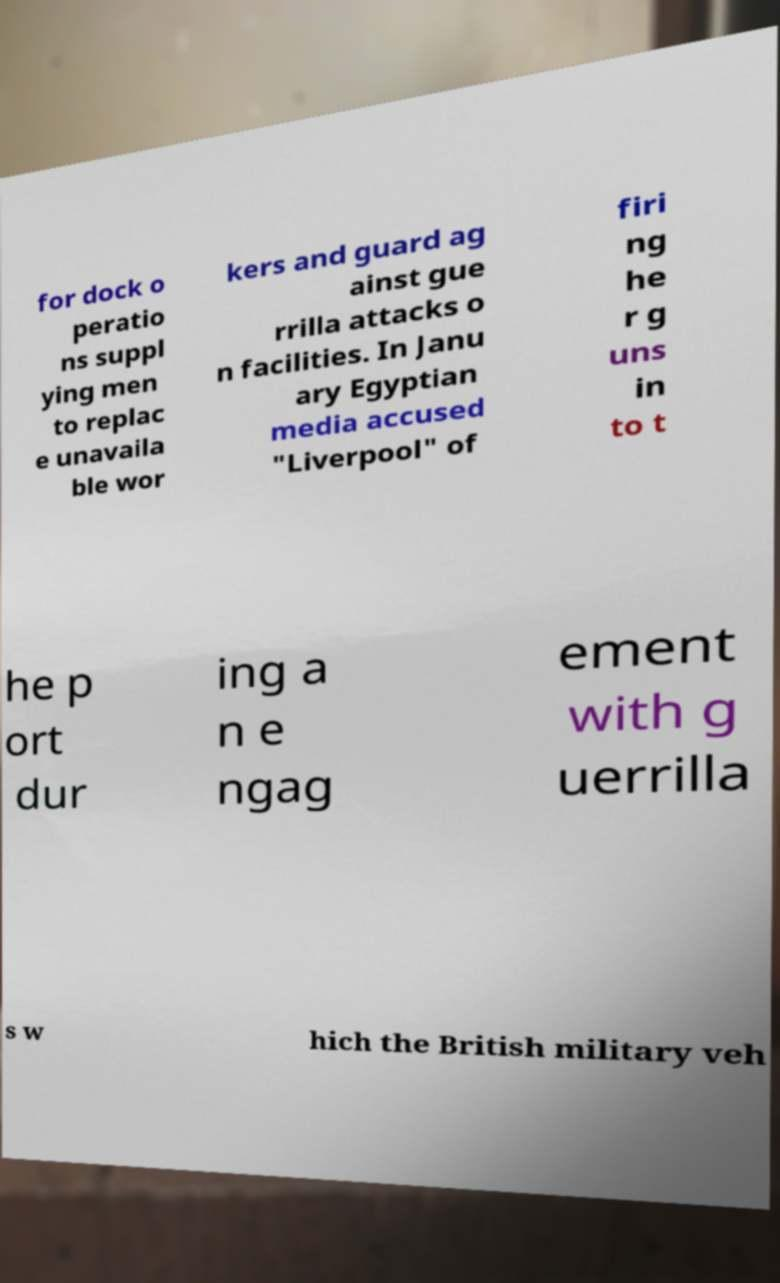Can you accurately transcribe the text from the provided image for me? for dock o peratio ns suppl ying men to replac e unavaila ble wor kers and guard ag ainst gue rrilla attacks o n facilities. In Janu ary Egyptian media accused "Liverpool" of firi ng he r g uns in to t he p ort dur ing a n e ngag ement with g uerrilla s w hich the British military veh 